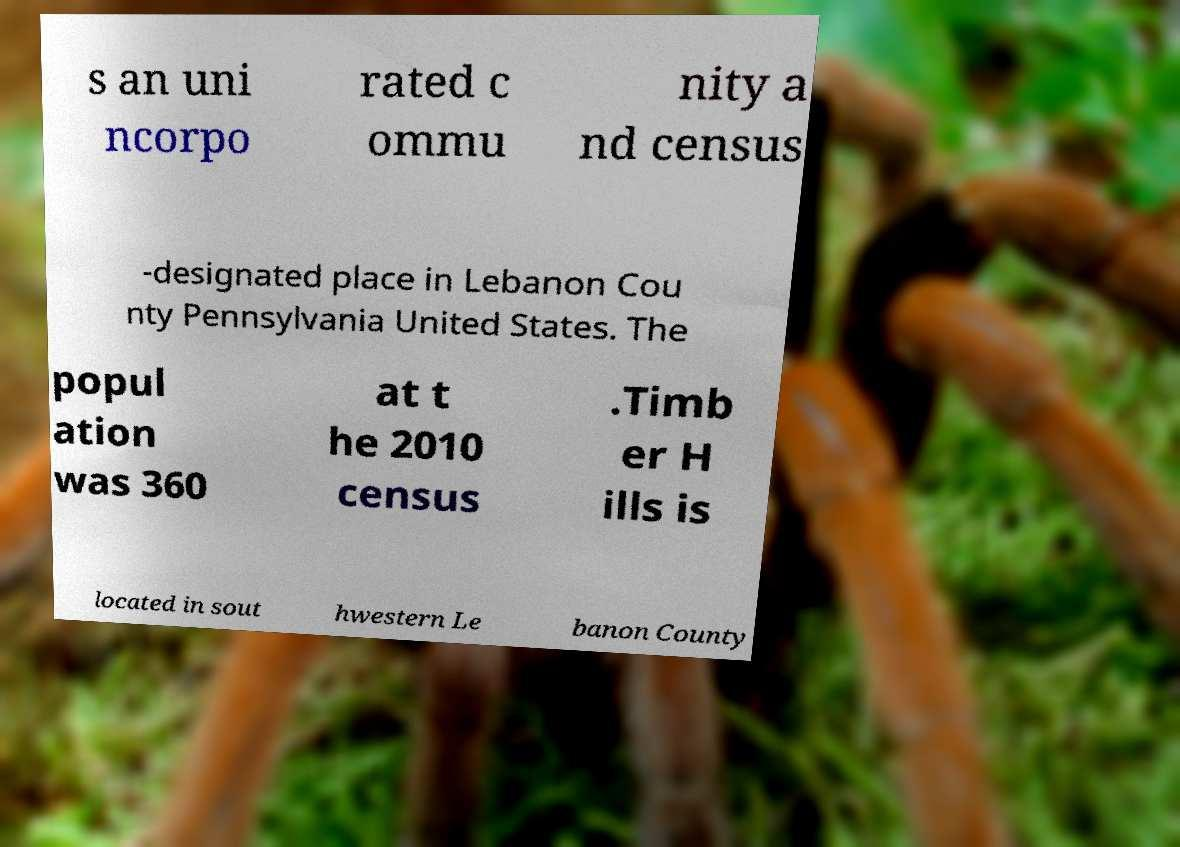For documentation purposes, I need the text within this image transcribed. Could you provide that? s an uni ncorpo rated c ommu nity a nd census -designated place in Lebanon Cou nty Pennsylvania United States. The popul ation was 360 at t he 2010 census .Timb er H ills is located in sout hwestern Le banon County 